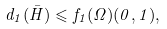<formula> <loc_0><loc_0><loc_500><loc_500>d _ { 1 } ( \bar { H } ) \leqslant f _ { 1 } ( \Omega ) ( 0 , 1 ) ,</formula> 